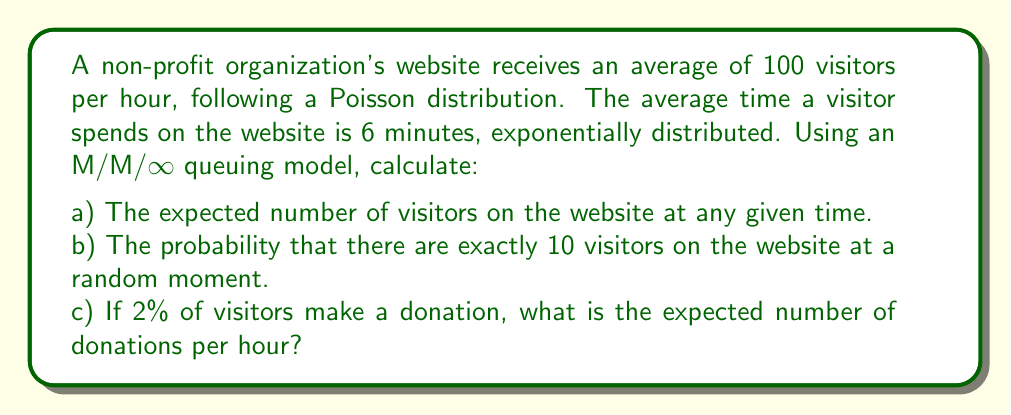Solve this math problem. Let's approach this step-by-step using queuing theory:

1) First, we need to identify the parameters of our M/M/∞ queue:
   - Arrival rate (λ) = 100 visitors/hour
   - Service rate (μ) = 1/(6/60) = 10 visitors/hour (as 6 minutes = 1/10 hour)

2) For an M/M/∞ queue:
   a) The expected number of visitors (L) is given by:
      $$L = \frac{\lambda}{\mu} = \frac{100}{10} = 10$$

   b) The probability of n visitors in the system follows a Poisson distribution with mean L:
      $$P(n) = \frac{L^n e^{-L}}{n!}$$
      
      For n = 10:
      $$P(10) = \frac{10^{10} e^{-10}}{10!} \approx 0.1251$$

   c) The expected number of donations per hour:
      - Number of visitors per hour = 100
      - Donation rate = 2% = 0.02
      Expected donations = 100 * 0.02 = 2 donations/hour

This model helps the non-profit understand website traffic patterns and potential donation rates, which can be used to optimize the online donation system and plan for server capacity.
Answer: a) 10 visitors
b) 0.1251
c) 2 donations/hour 